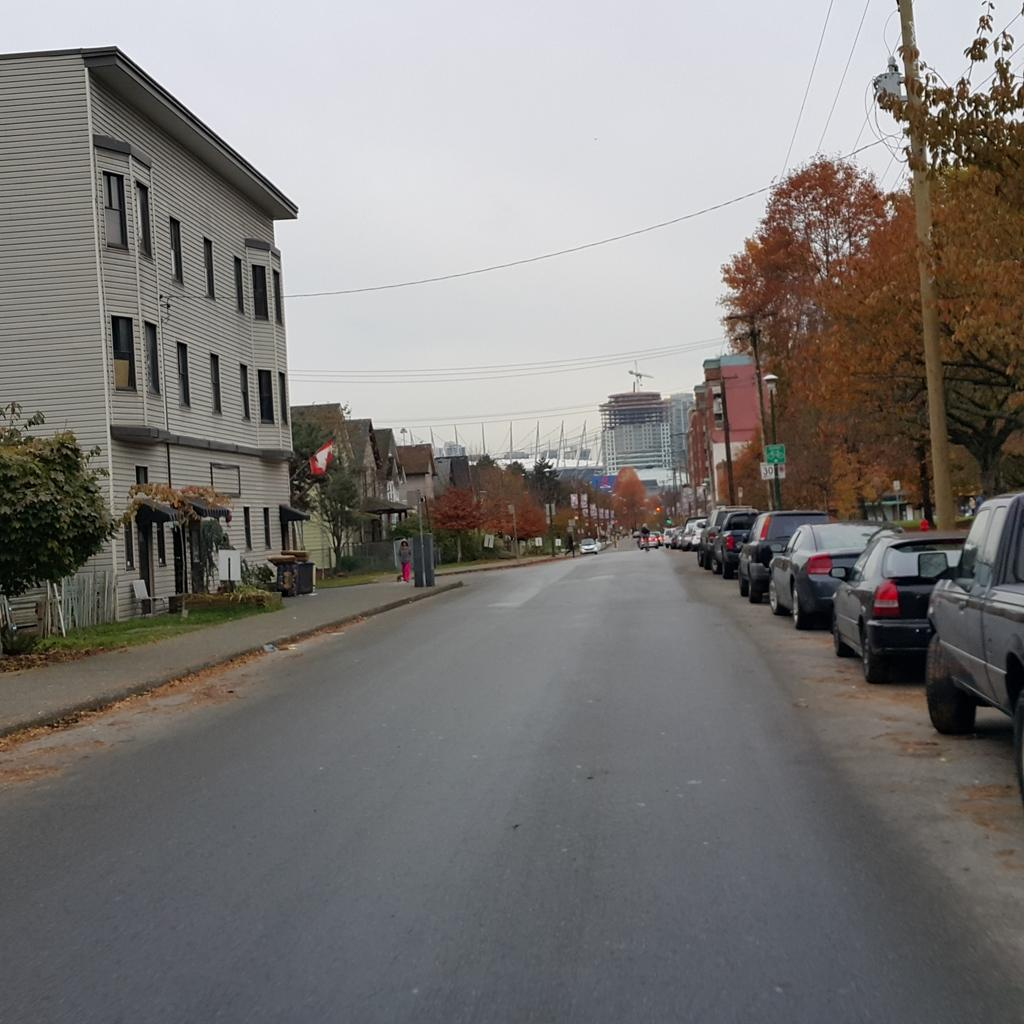What type of structures can be seen in the image? There are buildings in the image. What else is present in the image besides buildings? There are vehicles, a fence, trees, poles with wires attached, and the sky visible in the background. Can you describe the presence of people in the image? There are people in the background of the image. What type of mask is being worn by the cloud in the image? There is no cloud or mask present in the image. Is there a shop visible in the image? There is no shop mentioned in the provided facts, so it cannot be determined if one is present in the image. 